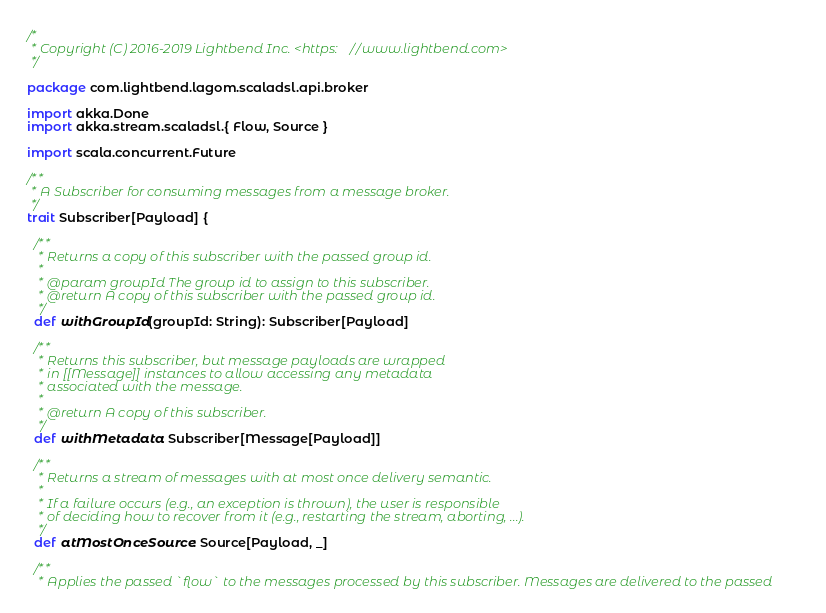Convert code to text. <code><loc_0><loc_0><loc_500><loc_500><_Scala_>/*
 * Copyright (C) 2016-2019 Lightbend Inc. <https://www.lightbend.com>
 */

package com.lightbend.lagom.scaladsl.api.broker

import akka.Done
import akka.stream.scaladsl.{ Flow, Source }

import scala.concurrent.Future

/**
 * A Subscriber for consuming messages from a message broker.
 */
trait Subscriber[Payload] {

  /**
   * Returns a copy of this subscriber with the passed group id.
   *
   * @param groupId The group id to assign to this subscriber.
   * @return A copy of this subscriber with the passed group id.
   */
  def withGroupId(groupId: String): Subscriber[Payload]

  /**
   * Returns this subscriber, but message payloads are wrapped
   * in [[Message]] instances to allow accessing any metadata
   * associated with the message.
   *
   * @return A copy of this subscriber.
   */
  def withMetadata: Subscriber[Message[Payload]]

  /**
   * Returns a stream of messages with at most once delivery semantic.
   *
   * If a failure occurs (e.g., an exception is thrown), the user is responsible
   * of deciding how to recover from it (e.g., restarting the stream, aborting, ...).
   */
  def atMostOnceSource: Source[Payload, _]

  /**
   * Applies the passed `flow` to the messages processed by this subscriber. Messages are delivered to the passed</code> 